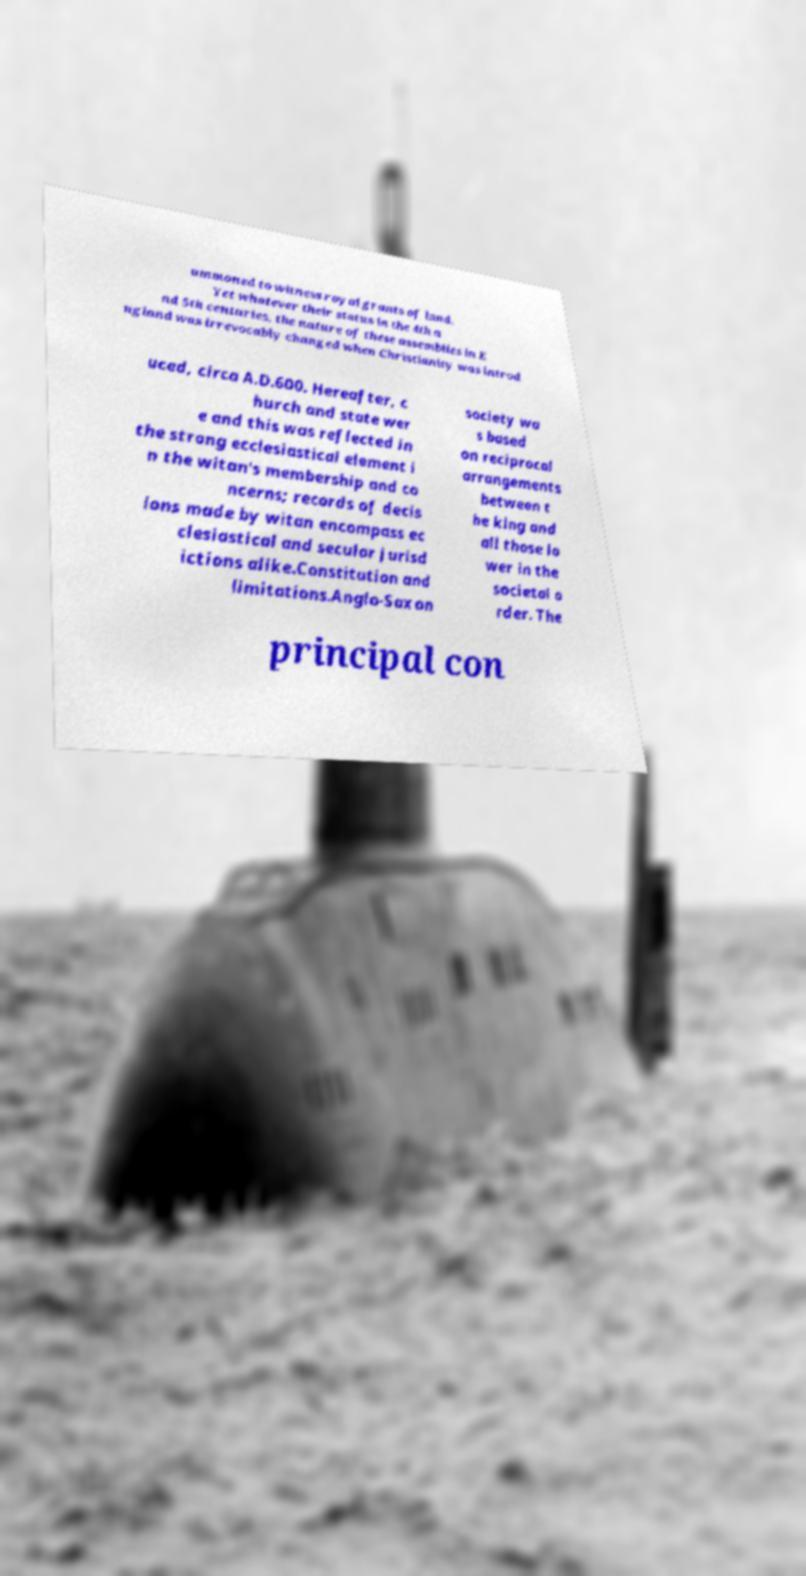Can you read and provide the text displayed in the image?This photo seems to have some interesting text. Can you extract and type it out for me? ummoned to witness royal grants of land. Yet whatever their status in the 4th a nd 5th centuries, the nature of these assemblies in E ngland was irrevocably changed when Christianity was introd uced, circa A.D.600. Hereafter, c hurch and state wer e and this was reflected in the strong ecclesiastical element i n the witan's membership and co ncerns; records of decis ions made by witan encompass ec clesiastical and secular jurisd ictions alike.Constitution and limitations.Anglo-Saxon society wa s based on reciprocal arrangements between t he king and all those lo wer in the societal o rder. The principal con 